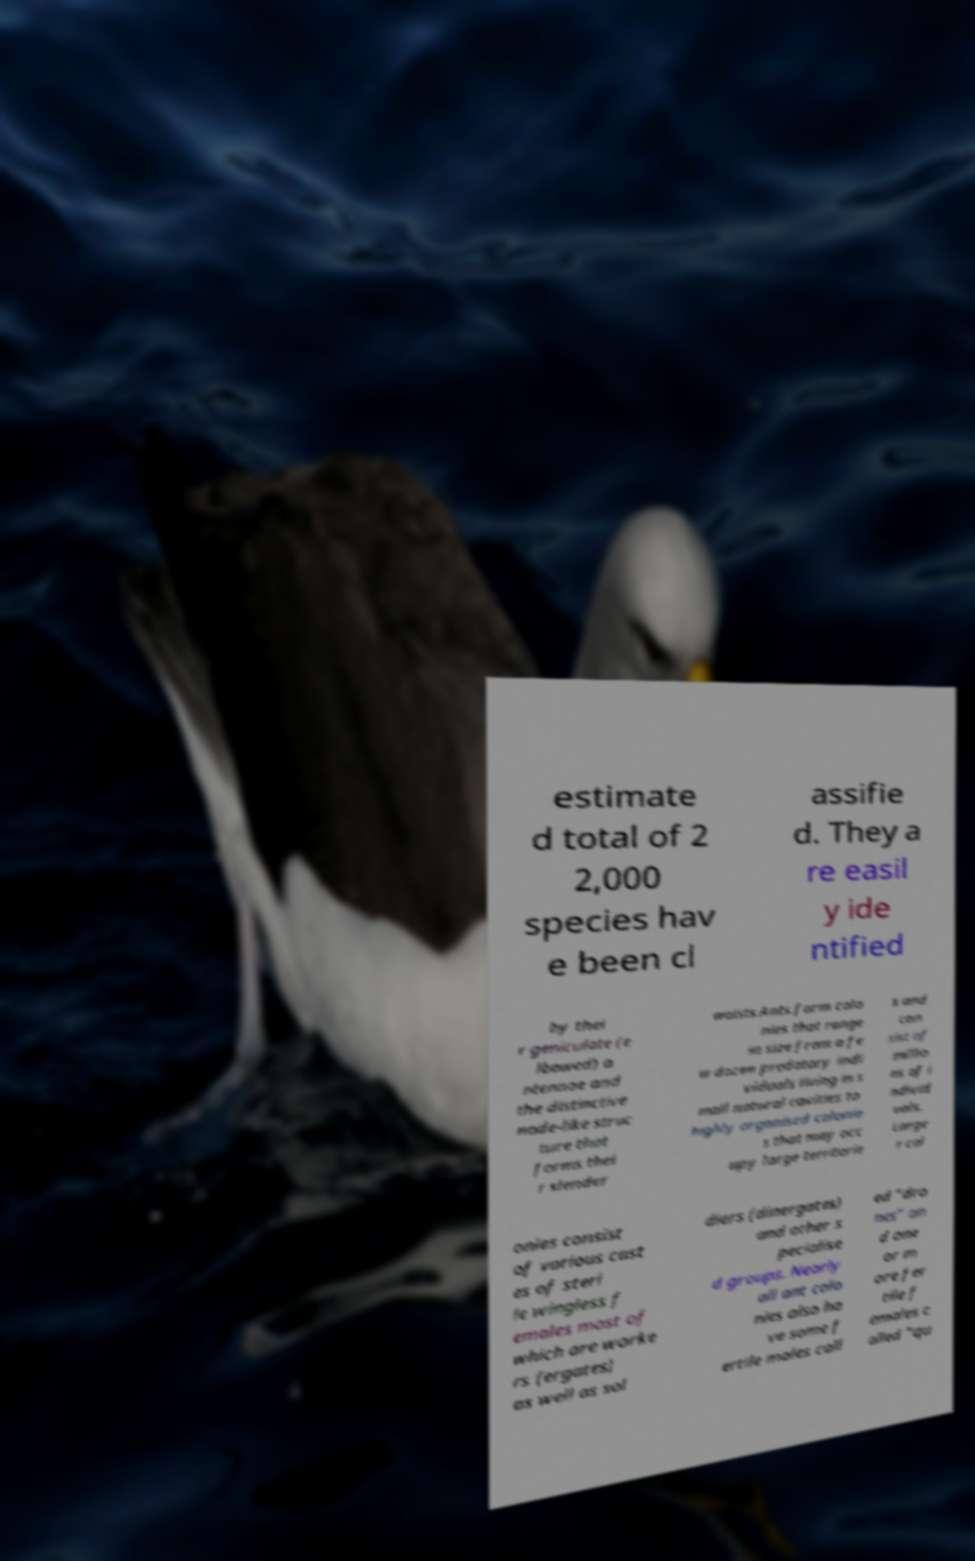Could you extract and type out the text from this image? estimate d total of 2 2,000 species hav e been cl assifie d. They a re easil y ide ntified by thei r geniculate (e lbowed) a ntennae and the distinctive node-like struc ture that forms thei r slender waists.Ants form colo nies that range in size from a fe w dozen predatory indi viduals living in s mall natural cavities to highly organised colonie s that may occ upy large territorie s and con sist of millio ns of i ndivid uals. Large r col onies consist of various cast es of steri le wingless f emales most of which are worke rs (ergates) as well as sol diers (dinergates) and other s pecialise d groups. Nearly all ant colo nies also ha ve some f ertile males call ed "dro nes" an d one or m ore fer tile f emales c alled "qu 